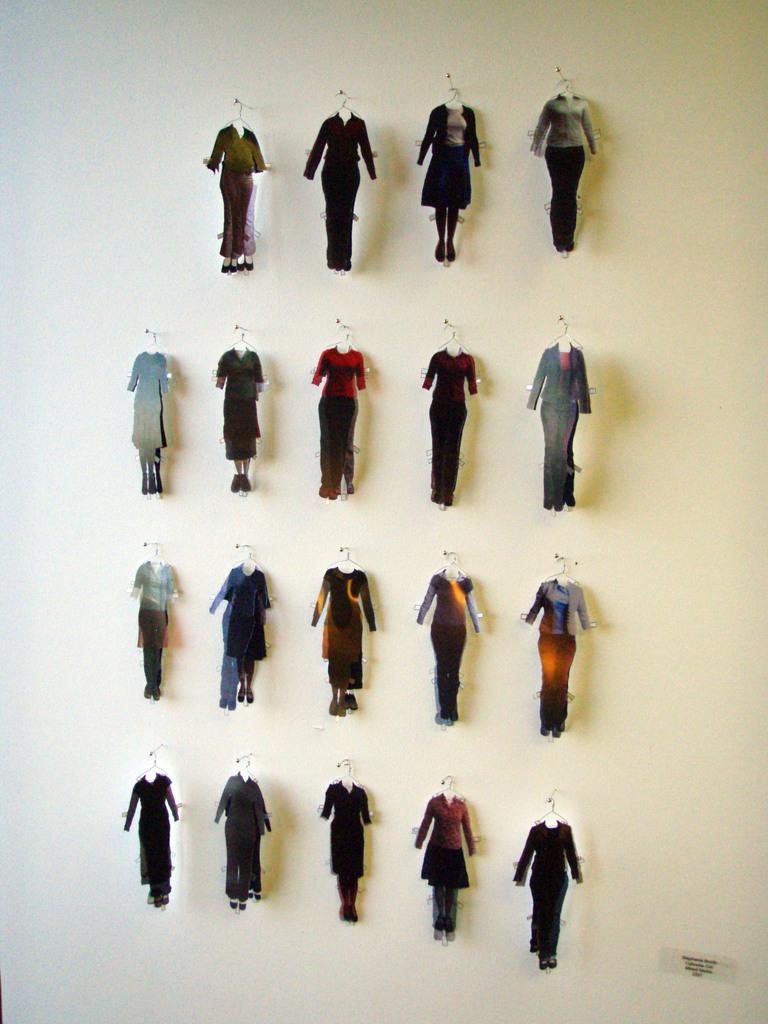In one or two sentences, can you explain what this image depicts? In the foreground of this image, there are cardboard pieces in the shape of a human body which are hanging to the pins on the wall. 